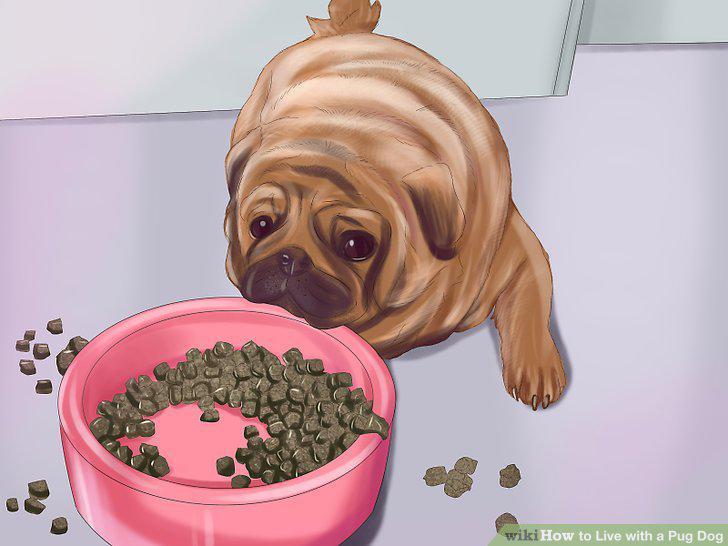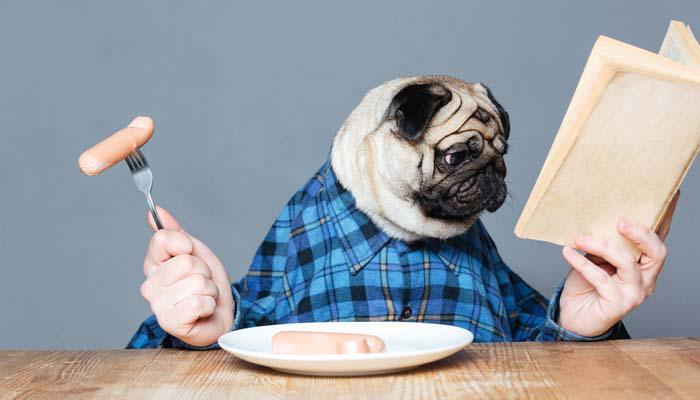The first image is the image on the left, the second image is the image on the right. Examine the images to the left and right. Is the description "The left image shows a pug with something edible in front of him, and the right image shows a pug in a collared shirt with a bowl in front of him." accurate? Answer yes or no. Yes. 